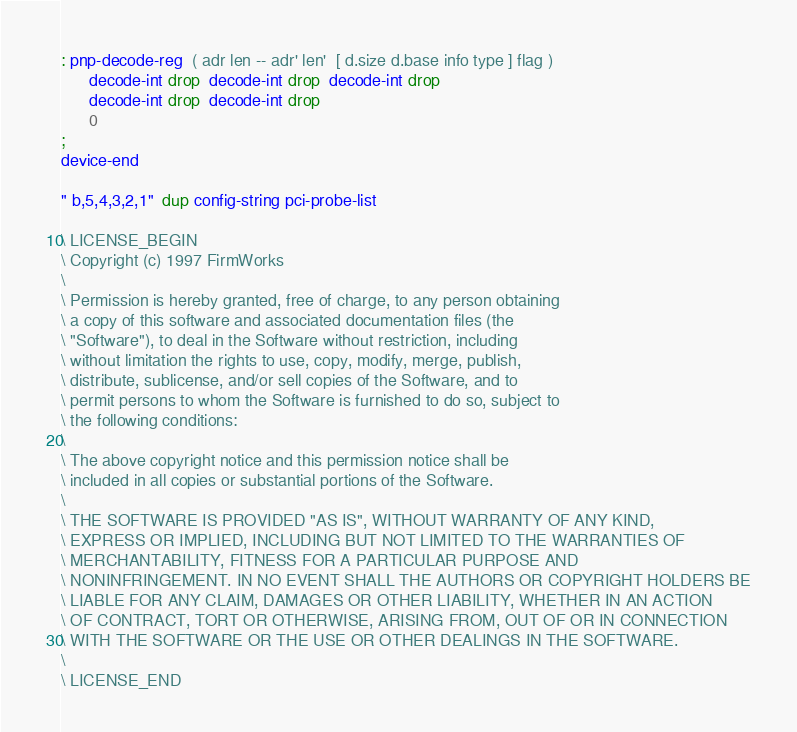<code> <loc_0><loc_0><loc_500><loc_500><_Forth_>: pnp-decode-reg  ( adr len -- adr' len'  [ d.size d.base info type ] flag )
      decode-int drop  decode-int drop  decode-int drop
      decode-int drop  decode-int drop
      0
;
device-end

" b,5,4,3,2,1"  dup config-string pci-probe-list

\ LICENSE_BEGIN
\ Copyright (c) 1997 FirmWorks
\
\ Permission is hereby granted, free of charge, to any person obtaining
\ a copy of this software and associated documentation files (the
\ "Software"), to deal in the Software without restriction, including
\ without limitation the rights to use, copy, modify, merge, publish,
\ distribute, sublicense, and/or sell copies of the Software, and to
\ permit persons to whom the Software is furnished to do so, subject to
\ the following conditions:
\
\ The above copyright notice and this permission notice shall be
\ included in all copies or substantial portions of the Software.
\
\ THE SOFTWARE IS PROVIDED "AS IS", WITHOUT WARRANTY OF ANY KIND,
\ EXPRESS OR IMPLIED, INCLUDING BUT NOT LIMITED TO THE WARRANTIES OF
\ MERCHANTABILITY, FITNESS FOR A PARTICULAR PURPOSE AND
\ NONINFRINGEMENT. IN NO EVENT SHALL THE AUTHORS OR COPYRIGHT HOLDERS BE
\ LIABLE FOR ANY CLAIM, DAMAGES OR OTHER LIABILITY, WHETHER IN AN ACTION
\ OF CONTRACT, TORT OR OTHERWISE, ARISING FROM, OUT OF OR IN CONNECTION
\ WITH THE SOFTWARE OR THE USE OR OTHER DEALINGS IN THE SOFTWARE.
\
\ LICENSE_END

</code> 